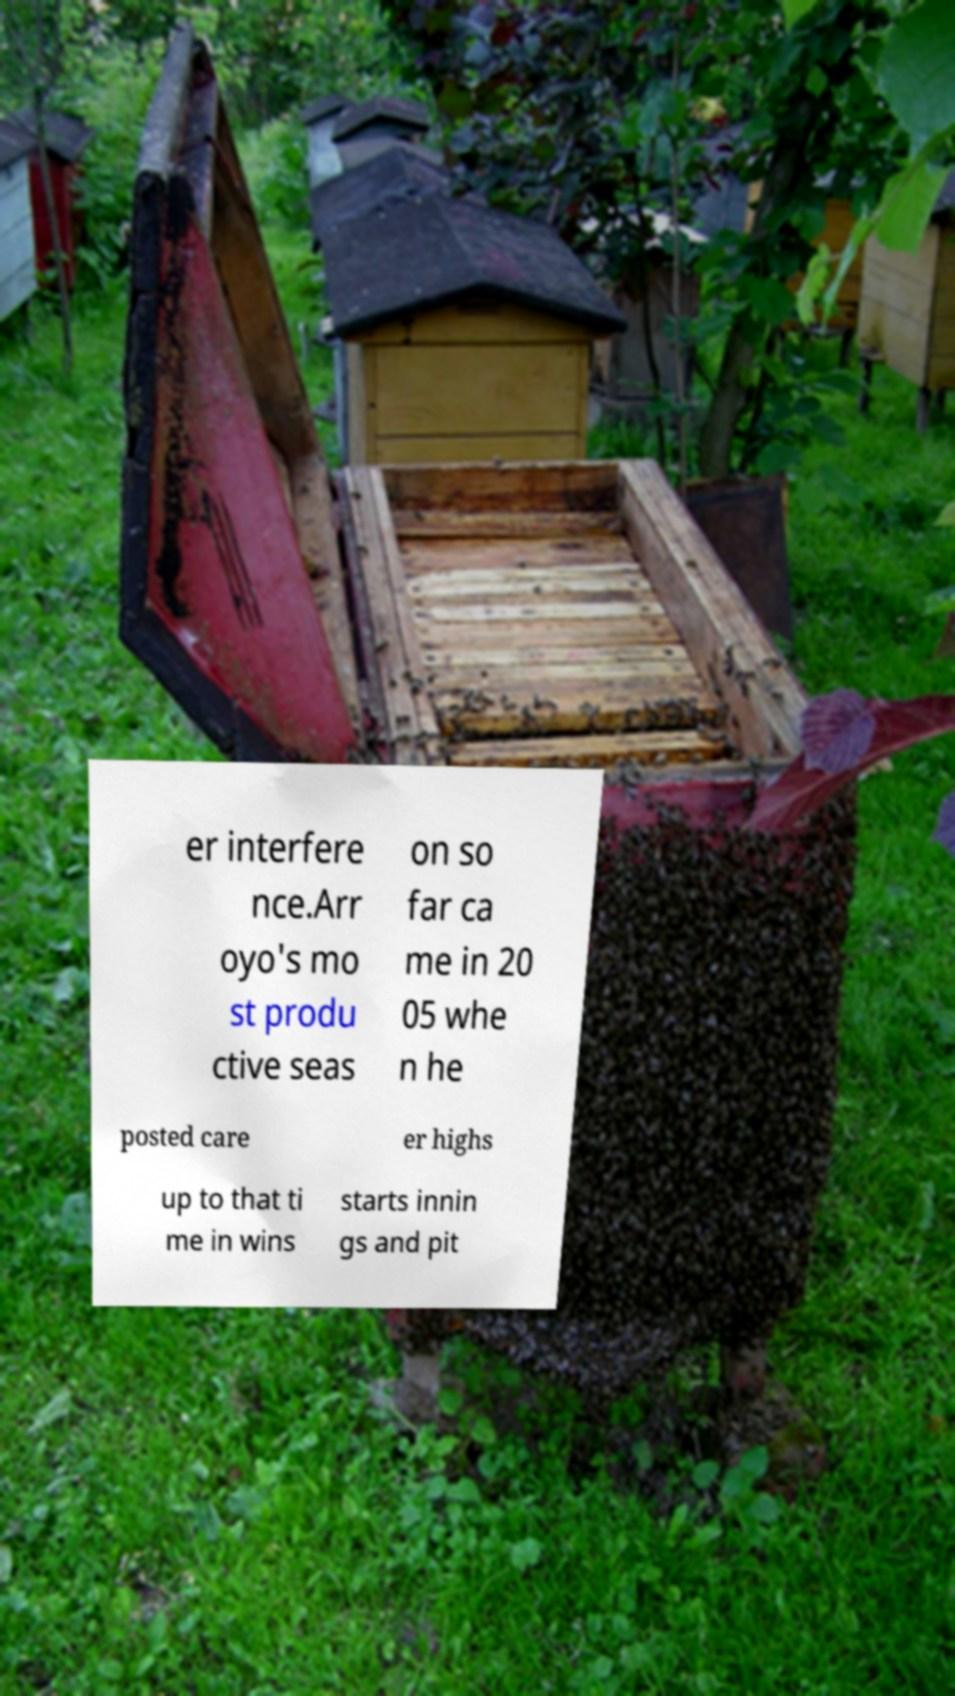For documentation purposes, I need the text within this image transcribed. Could you provide that? er interfere nce.Arr oyo's mo st produ ctive seas on so far ca me in 20 05 whe n he posted care er highs up to that ti me in wins starts innin gs and pit 